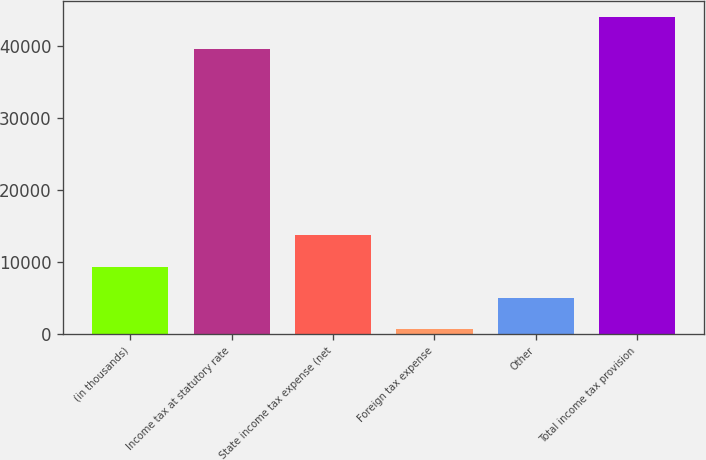<chart> <loc_0><loc_0><loc_500><loc_500><bar_chart><fcel>(in thousands)<fcel>Income tax at statutory rate<fcel>State income tax expense (net<fcel>Foreign tax expense<fcel>Other<fcel>Total income tax provision<nl><fcel>9314.4<fcel>39534<fcel>13652.6<fcel>638<fcel>4976.2<fcel>44020<nl></chart> 